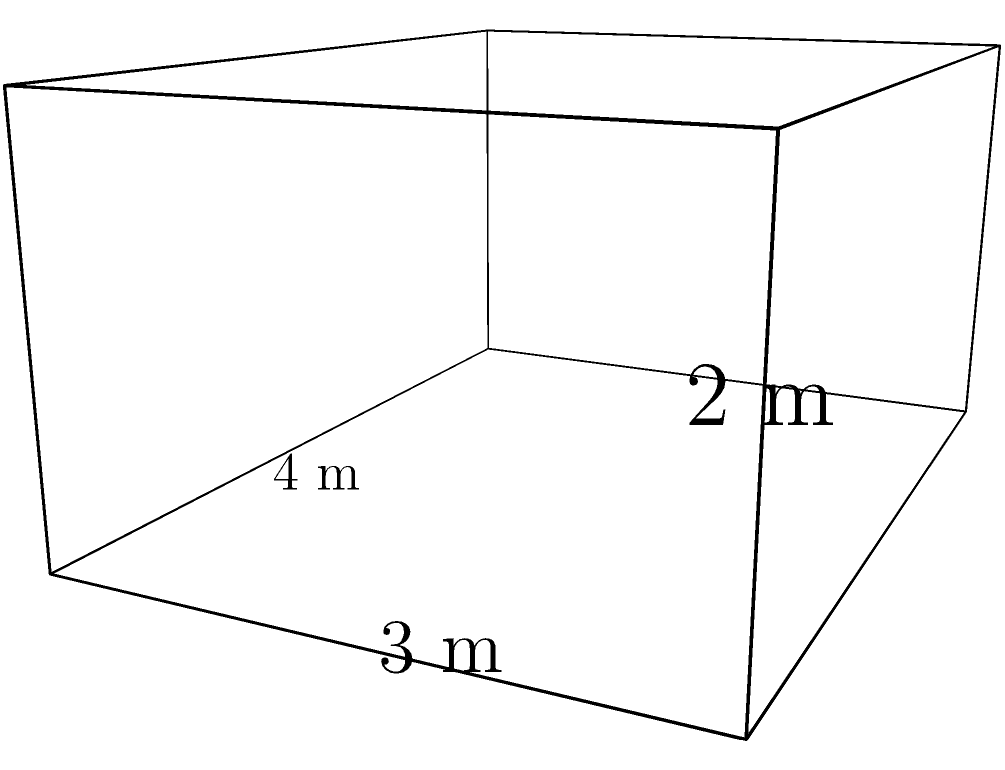Given a rectangular prism with dimensions 4 m × 3 m × 2 m, calculate its surface area. How might this calculation be relevant in modeling the spread of airborne pathogens in a confined space? To calculate the surface area of a rectangular prism, we need to sum the areas of all six faces. Let's approach this step-by-step:

1) The rectangular prism has three pairs of identical faces:
   - Two faces with dimensions 4 m × 3 m (front and back)
   - Two faces with dimensions 4 m × 2 m (top and bottom)
   - Two faces with dimensions 3 m × 2 m (left and right sides)

2) Calculate the area of each pair:
   - Area of front/back: $A_1 = 4 \text{ m} \times 3 \text{ m} = 12 \text{ m}^2$
   - Area of top/bottom: $A_2 = 4 \text{ m} \times 2 \text{ m} = 8 \text{ m}^2$
   - Area of sides: $A_3 = 3 \text{ m} \times 2 \text{ m} = 6 \text{ m}^2$

3) Sum up all areas, considering there are two of each:
   Total Surface Area = $2(A_1 + A_2 + A_3)$
   $= 2(12 \text{ m}^2 + 8 \text{ m}^2 + 6 \text{ m}^2)$
   $= 2(26 \text{ m}^2) = 52 \text{ m}^2$

This calculation is relevant to modeling airborne pathogen spread as it quantifies the total area available for particle deposition or interaction. In epidemiological models, the surface area-to-volume ratio can influence factors such as pathogen survival time, air circulation patterns, and the effectiveness of disinfection protocols.
Answer: $52 \text{ m}^2$ 